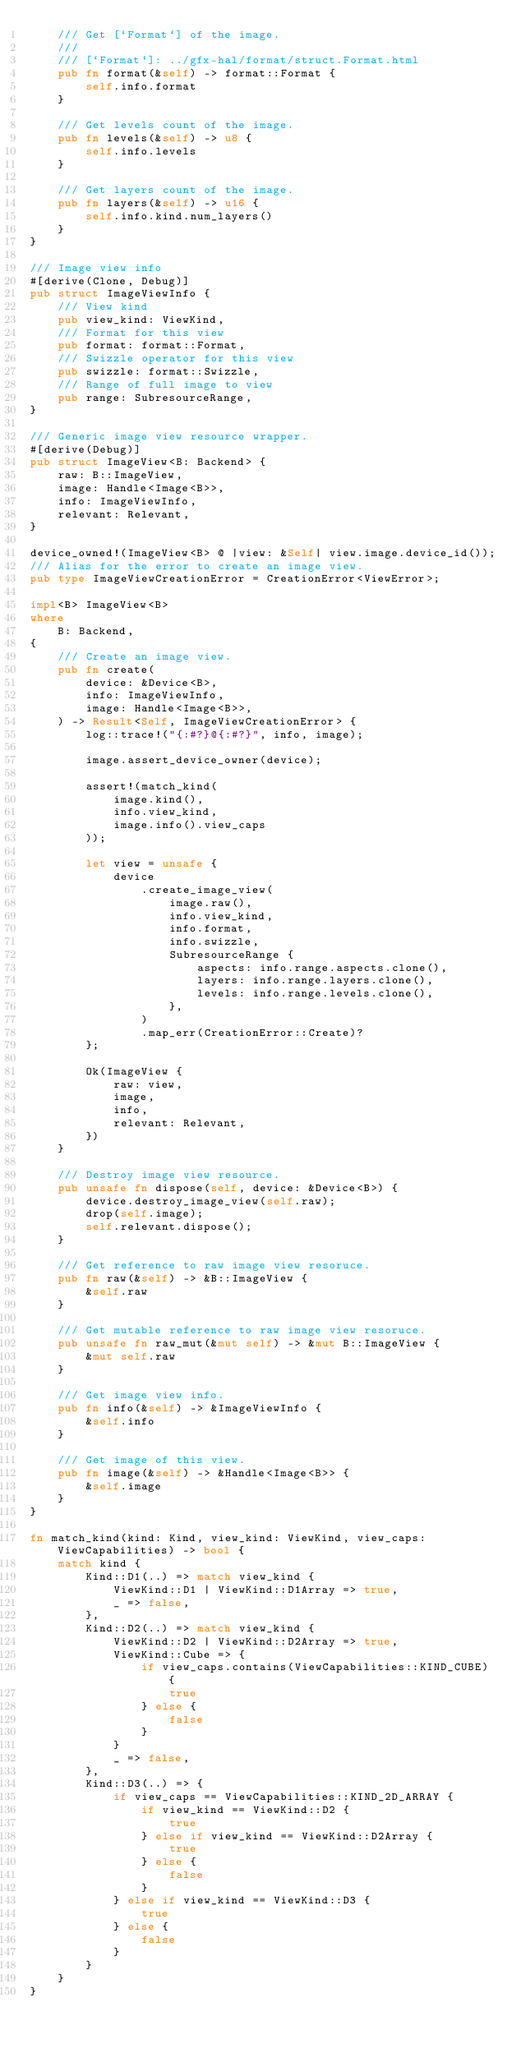Convert code to text. <code><loc_0><loc_0><loc_500><loc_500><_Rust_>    /// Get [`Format`] of the image.
    ///
    /// [`Format`]: ../gfx-hal/format/struct.Format.html
    pub fn format(&self) -> format::Format {
        self.info.format
    }

    /// Get levels count of the image.
    pub fn levels(&self) -> u8 {
        self.info.levels
    }

    /// Get layers count of the image.
    pub fn layers(&self) -> u16 {
        self.info.kind.num_layers()
    }
}

/// Image view info
#[derive(Clone, Debug)]
pub struct ImageViewInfo {
    /// View kind
    pub view_kind: ViewKind,
    /// Format for this view
    pub format: format::Format,
    /// Swizzle operator for this view
    pub swizzle: format::Swizzle,
    /// Range of full image to view
    pub range: SubresourceRange,
}

/// Generic image view resource wrapper.
#[derive(Debug)]
pub struct ImageView<B: Backend> {
    raw: B::ImageView,
    image: Handle<Image<B>>,
    info: ImageViewInfo,
    relevant: Relevant,
}

device_owned!(ImageView<B> @ |view: &Self| view.image.device_id());
/// Alias for the error to create an image view.
pub type ImageViewCreationError = CreationError<ViewError>;

impl<B> ImageView<B>
where
    B: Backend,
{
    /// Create an image view.
    pub fn create(
        device: &Device<B>,
        info: ImageViewInfo,
        image: Handle<Image<B>>,
    ) -> Result<Self, ImageViewCreationError> {
        log::trace!("{:#?}@{:#?}", info, image);

        image.assert_device_owner(device);

        assert!(match_kind(
            image.kind(),
            info.view_kind,
            image.info().view_caps
        ));

        let view = unsafe {
            device
                .create_image_view(
                    image.raw(),
                    info.view_kind,
                    info.format,
                    info.swizzle,
                    SubresourceRange {
                        aspects: info.range.aspects.clone(),
                        layers: info.range.layers.clone(),
                        levels: info.range.levels.clone(),
                    },
                )
                .map_err(CreationError::Create)?
        };

        Ok(ImageView {
            raw: view,
            image,
            info,
            relevant: Relevant,
        })
    }

    /// Destroy image view resource.
    pub unsafe fn dispose(self, device: &Device<B>) {
        device.destroy_image_view(self.raw);
        drop(self.image);
        self.relevant.dispose();
    }

    /// Get reference to raw image view resoruce.
    pub fn raw(&self) -> &B::ImageView {
        &self.raw
    }

    /// Get mutable reference to raw image view resoruce.
    pub unsafe fn raw_mut(&mut self) -> &mut B::ImageView {
        &mut self.raw
    }

    /// Get image view info.
    pub fn info(&self) -> &ImageViewInfo {
        &self.info
    }

    /// Get image of this view.
    pub fn image(&self) -> &Handle<Image<B>> {
        &self.image
    }
}

fn match_kind(kind: Kind, view_kind: ViewKind, view_caps: ViewCapabilities) -> bool {
    match kind {
        Kind::D1(..) => match view_kind {
            ViewKind::D1 | ViewKind::D1Array => true,
            _ => false,
        },
        Kind::D2(..) => match view_kind {
            ViewKind::D2 | ViewKind::D2Array => true,
            ViewKind::Cube => {
                if view_caps.contains(ViewCapabilities::KIND_CUBE) {
                    true
                } else {
                    false
                }
            }
            _ => false,
        },
        Kind::D3(..) => {
            if view_caps == ViewCapabilities::KIND_2D_ARRAY {
                if view_kind == ViewKind::D2 {
                    true
                } else if view_kind == ViewKind::D2Array {
                    true
                } else {
                    false
                }
            } else if view_kind == ViewKind::D3 {
                true
            } else {
                false
            }
        }
    }
}
</code> 